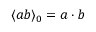<formula> <loc_0><loc_0><loc_500><loc_500>\langle a b \rangle _ { 0 } = a \cdot b</formula> 